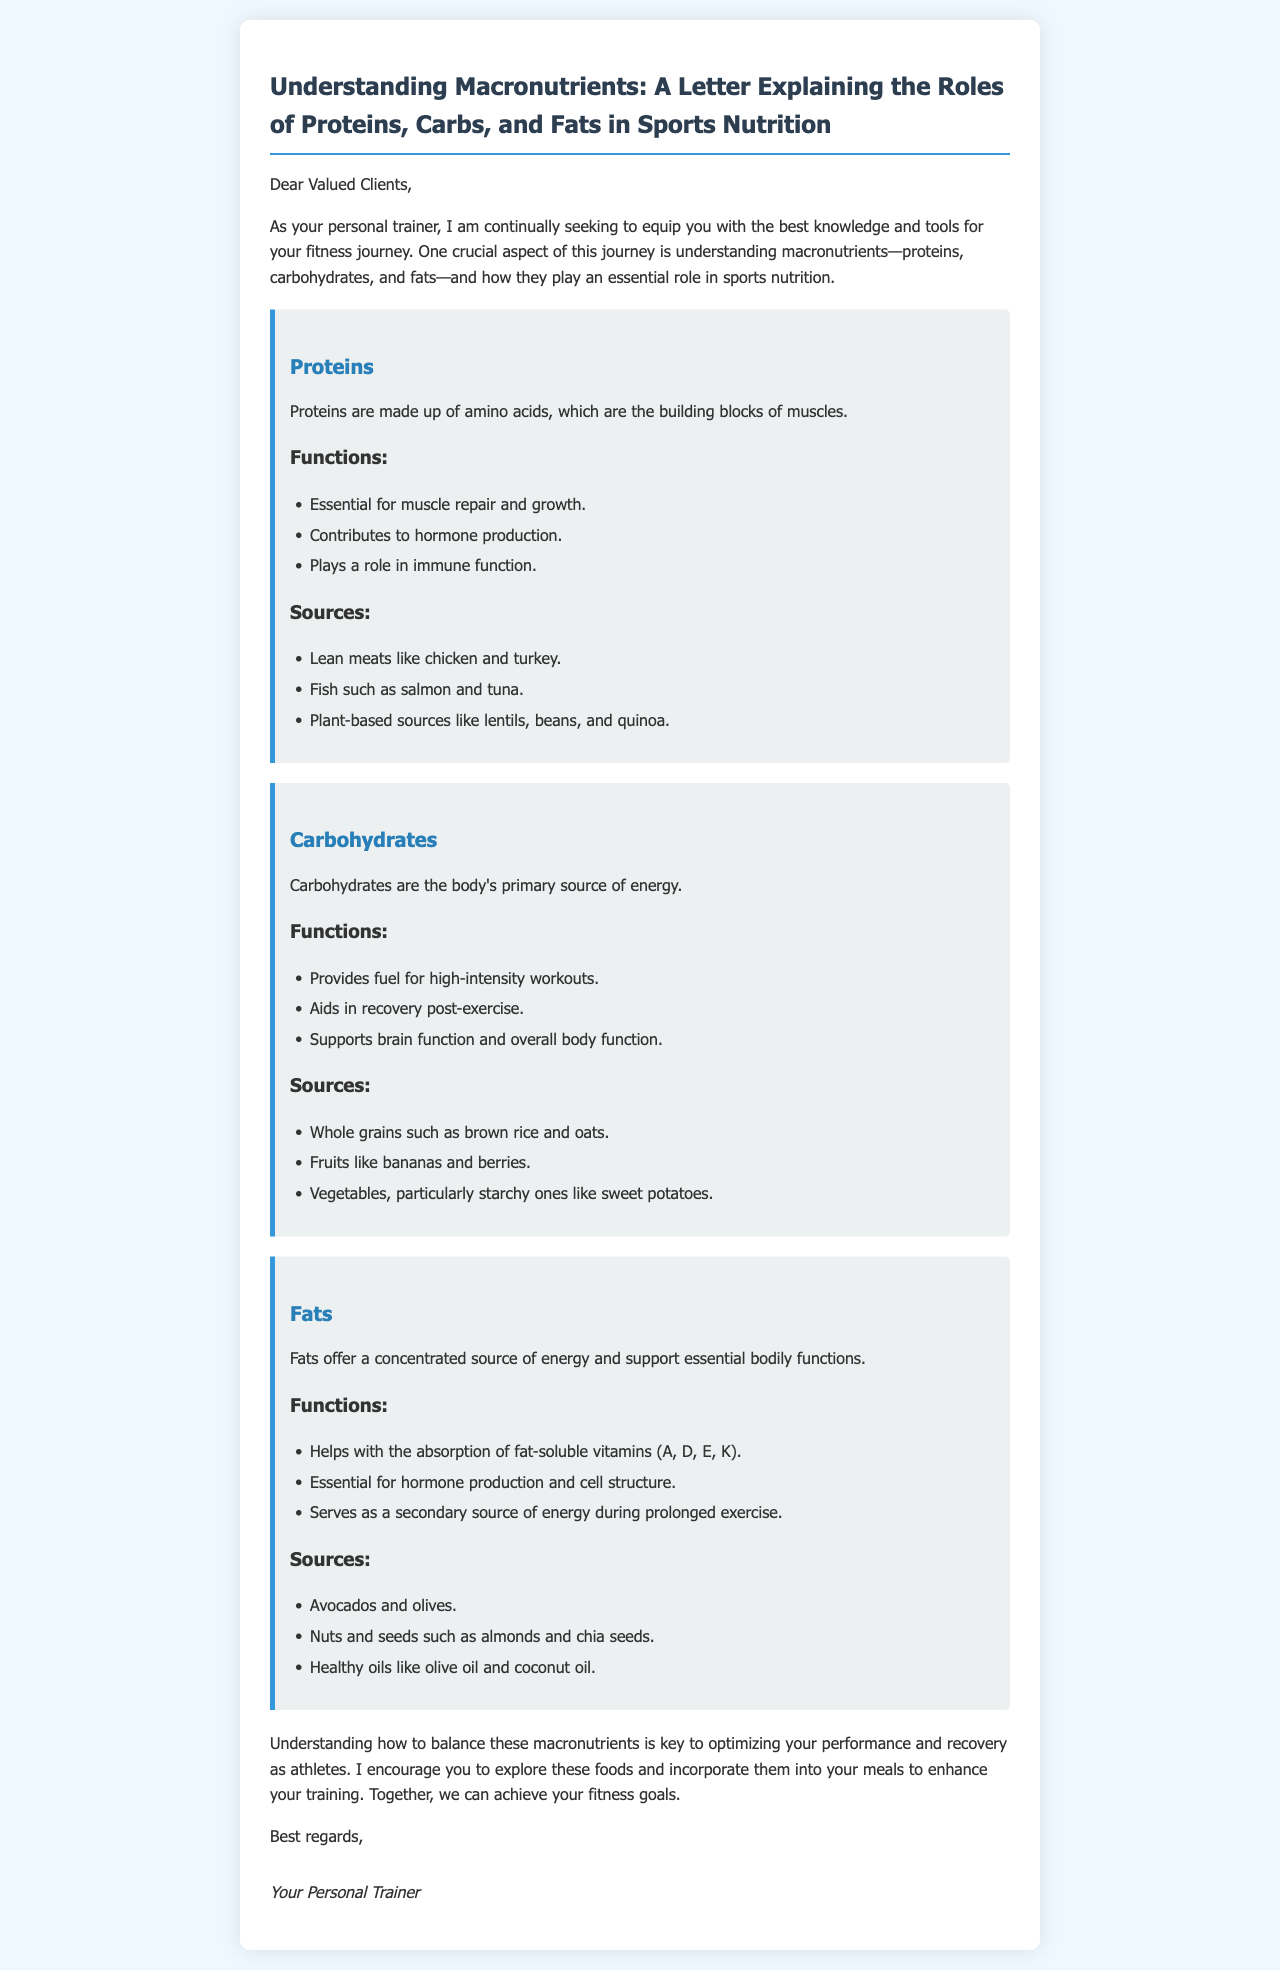What are the three macronutrients mentioned? The letter explicitly lists proteins, carbohydrates, and fats as the three macronutrients discussed.
Answer: proteins, carbohydrates, and fats What is the primary source of energy for the body? The document states that carbohydrates are the body's primary source of energy.
Answer: carbohydrates Which food is suggested as a source of healthy fats? The letter mentions avocados and olives as sources of healthy fats.
Answer: avocados and olives What role do proteins play in muscle function? The letter states that proteins are essential for muscle repair and growth.
Answer: muscle repair and growth Which carbohydrate is noted for aiding recovery post-exercise? The document includes that carbohydrates help in recovery post-exercise, but it does not specify a particular carbohydrate in this context.
Answer: carbohydrates How do fats assist in vitamin absorption? The letter mentions that fats help in the absorption of fat-soluble vitamins (A, D, E, K).
Answer: absorption of fat-soluble vitamins What should clients incorporate into their meals for enhanced training? The letter advises clients to explore and incorporate proteins, carbohydrates, and fats into their meals.
Answer: proteins, carbohydrates, and fats Who is the author of the letter? The letter is signed as "Your Personal Trainer," indicating that the author is the personal trainer.
Answer: Your Personal Trainer What is a function of carbohydrates during high-intensity workouts? The document states that carbohydrates provide fuel for high-intensity workouts.
Answer: provides fuel for high-intensity workouts 